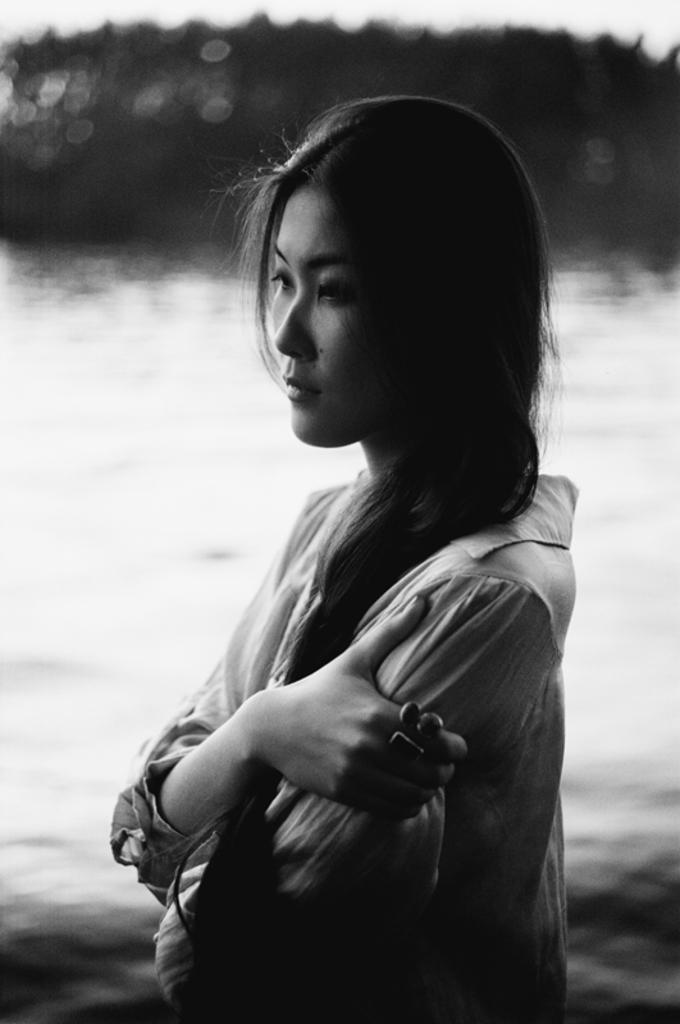What is the primary element visible in the image? There is water in the image. Can you describe the person in the image? There is a woman standing in the front of the image. What type of environment is depicted in the background? There are trees in the background of the image. What type of sweater is the woman wearing in the image? The image does not show the woman wearing a sweater, so it cannot be determined from the image. 